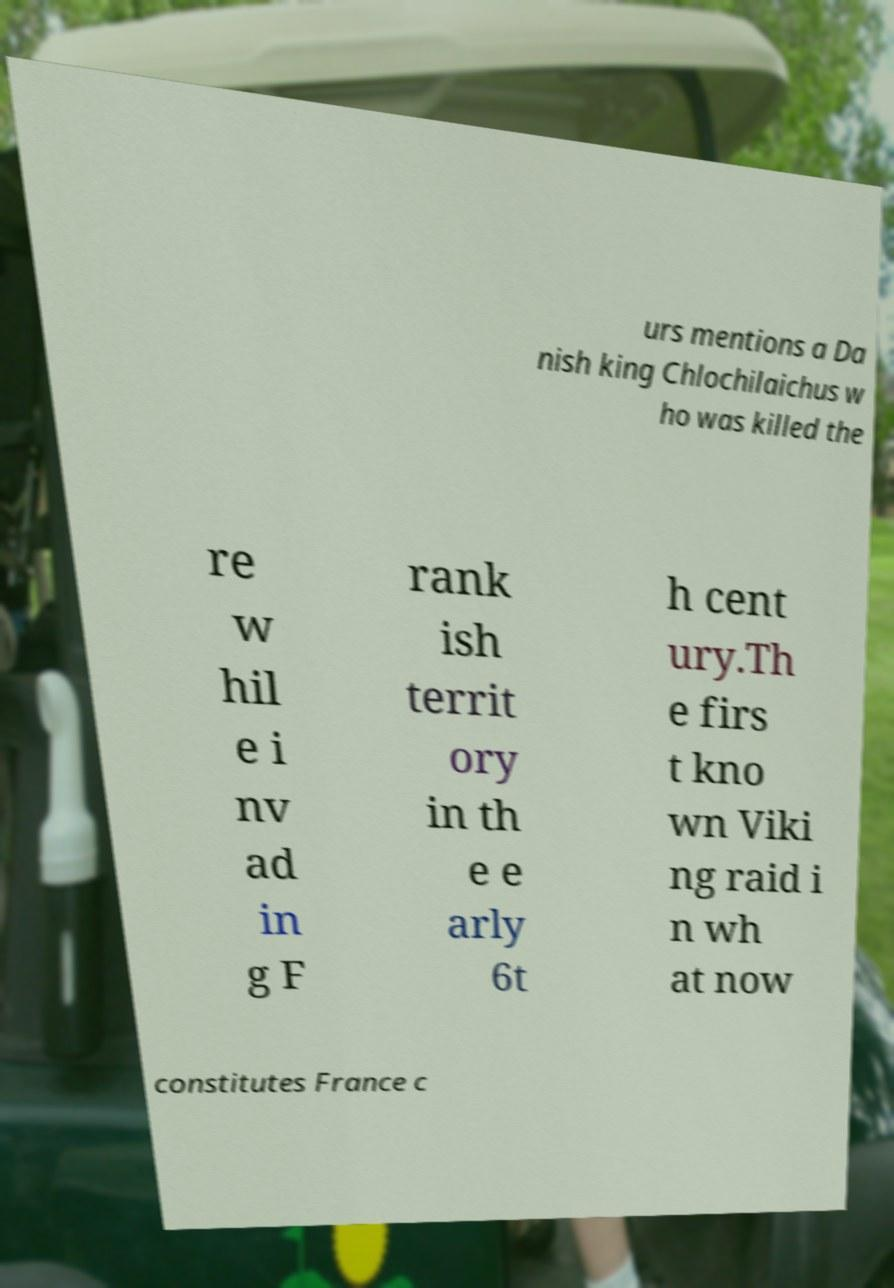For documentation purposes, I need the text within this image transcribed. Could you provide that? urs mentions a Da nish king Chlochilaichus w ho was killed the re w hil e i nv ad in g F rank ish territ ory in th e e arly 6t h cent ury.Th e firs t kno wn Viki ng raid i n wh at now constitutes France c 